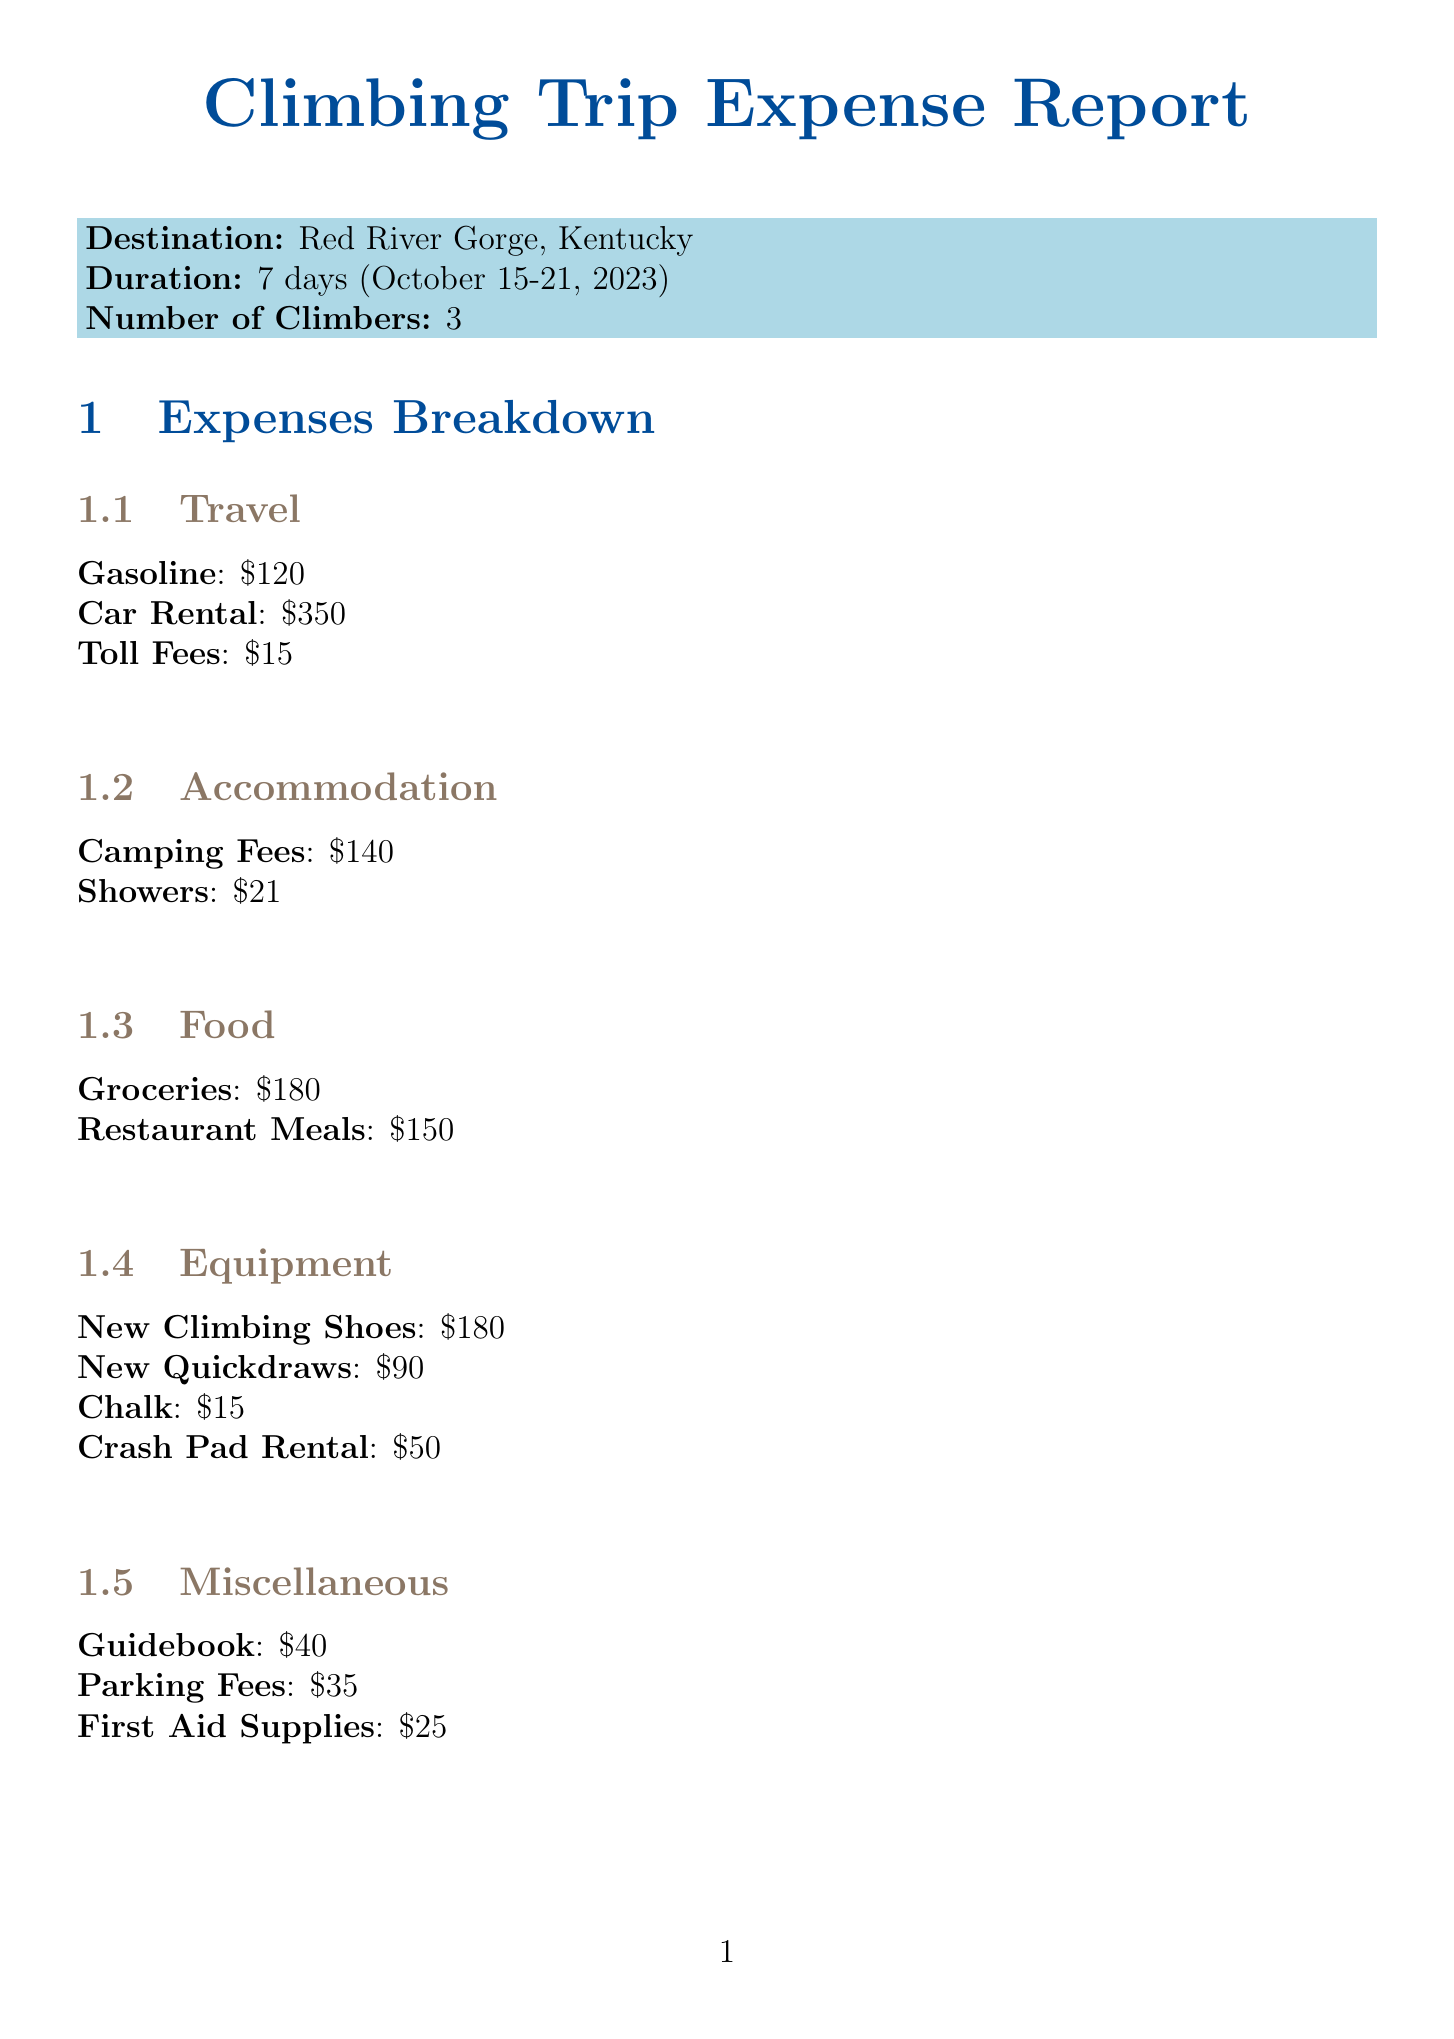What is the destination of the trip? The destination is clearly stated in the document as "Red River Gorge, Kentucky."
Answer: Red River Gorge, Kentucky What is the total budget for the trip? The total budget is mentioned in the budget summary section of the document as $1500.
Answer: 1500 How much was spent on groceries? The cost for groceries is listed under food expenses as $180.
Answer: 180 What was the cost of the crash pad rental? The cost of the crash pad rental is found under equipment costs as $50.
Answer: 50 How many climbers participated in the trip? The number of climbers is specified in the trip details as 3.
Answer: 3 What two training focuses are mentioned for future improvement? The document states training focuses as "Finger strength for crimpy routes" and "Endurance for longer climbs."
Answer: Finger strength for crimpy routes, Endurance for longer climbs What was the actual amount spent during the trip? The actual amount spent is mentioned in the budget summary section as $1411.
Answer: 1411 Which climbing route is rated 5.11b? The climbing route rated 5.11b is "Amarillo Sunset" as listed in the trip highlights.
Answer: Amarillo Sunset What items are suggested for future gear investments? The document suggests "Trad climbing rack for future trips" and "Rope for multi-pitch routes" as gear investments.
Answer: Trad climbing rack for future trips, Rope for multi-pitch routes 